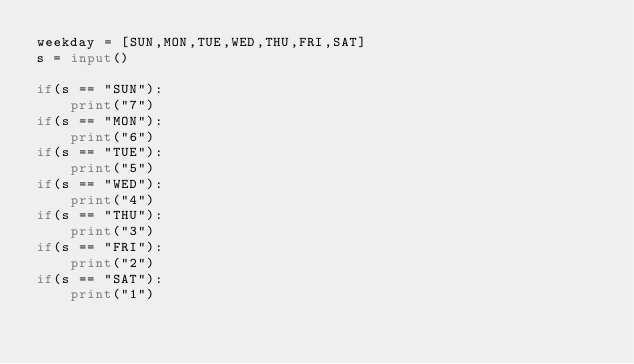<code> <loc_0><loc_0><loc_500><loc_500><_Python_>weekday = [SUN,MON,TUE,WED,THU,FRI,SAT]
s = input()

if(s == "SUN"):
    print("7")
if(s == "MON"):
    print("6")
if(s == "TUE"):
    print("5")
if(s == "WED"):
    print("4")
if(s == "THU"):
    print("3")
if(s == "FRI"):
    print("2")
if(s == "SAT"):
    print("1")</code> 